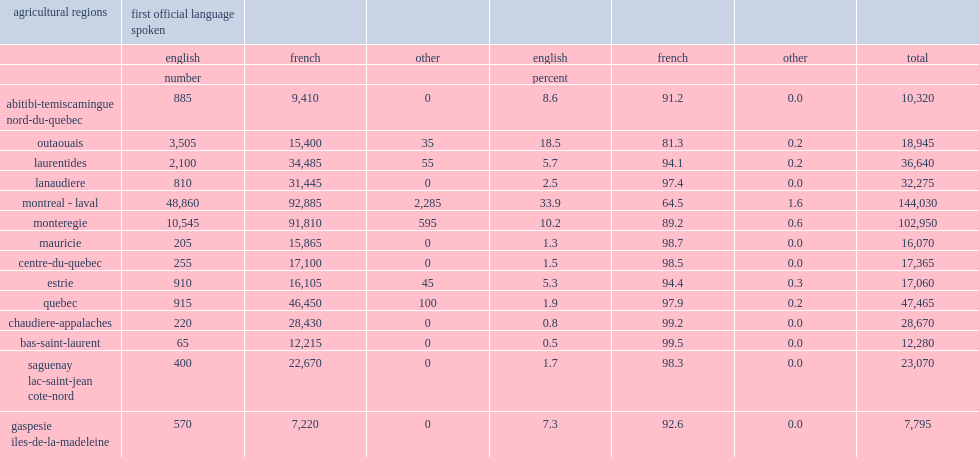What the number of workers aged 15 and over is in quebec's agri-food sector? 514935. List two main regions in the agri-food sector. Montreal - laval monteregie. What percent of quebec's english-language workers agri-food workers was in the montreal-laval region? 0.695566. What percent of quebec's english-language workers agri-food workers was in the monteregie region? 0.150117. What percentage of agri-food workers speaks english as their first language in montreal-laval? 33.9. What percentage of agri-food workers speaks english as their first language in monteregie? 10.2. 